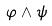<formula> <loc_0><loc_0><loc_500><loc_500>\varphi \wedge \psi</formula> 